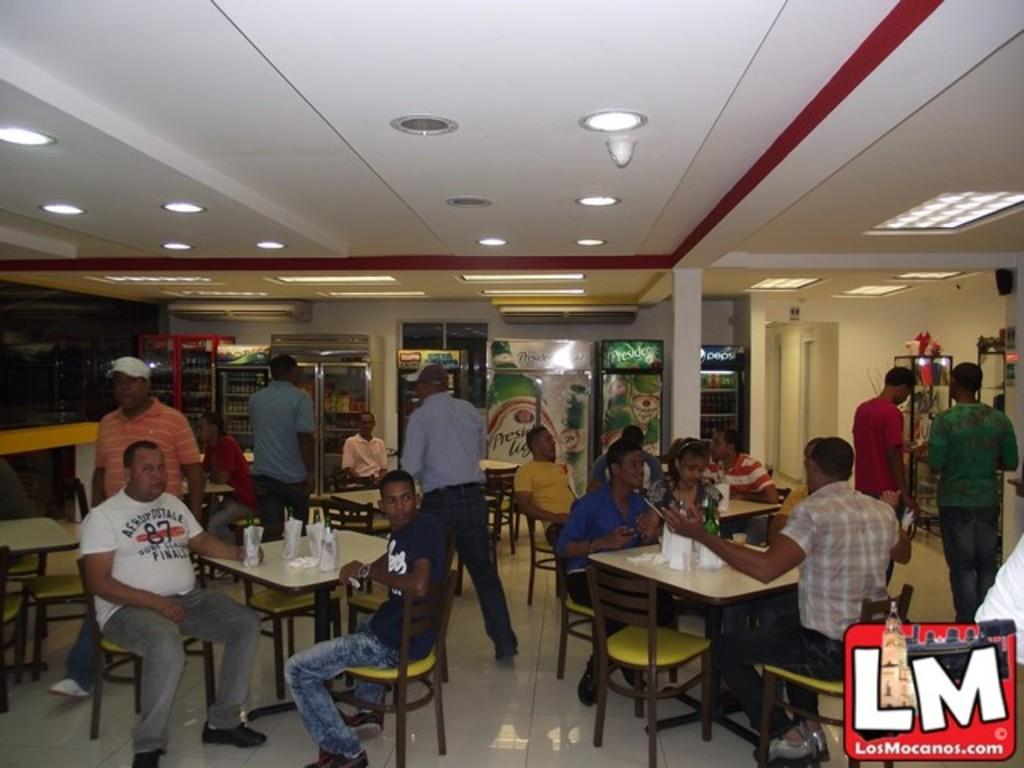What type of establishment is shown in the image? There is a restaurant in the image. Can you describe the people present in the restaurant? There are people present in the restaurant, some sitting on chairs and others walking. What might be on the tables in the restaurant? There are items on the table in the restaurant. How much mass does the meat on the table have in the image? There is no meat present in the image, so it is not possible to determine its mass. 